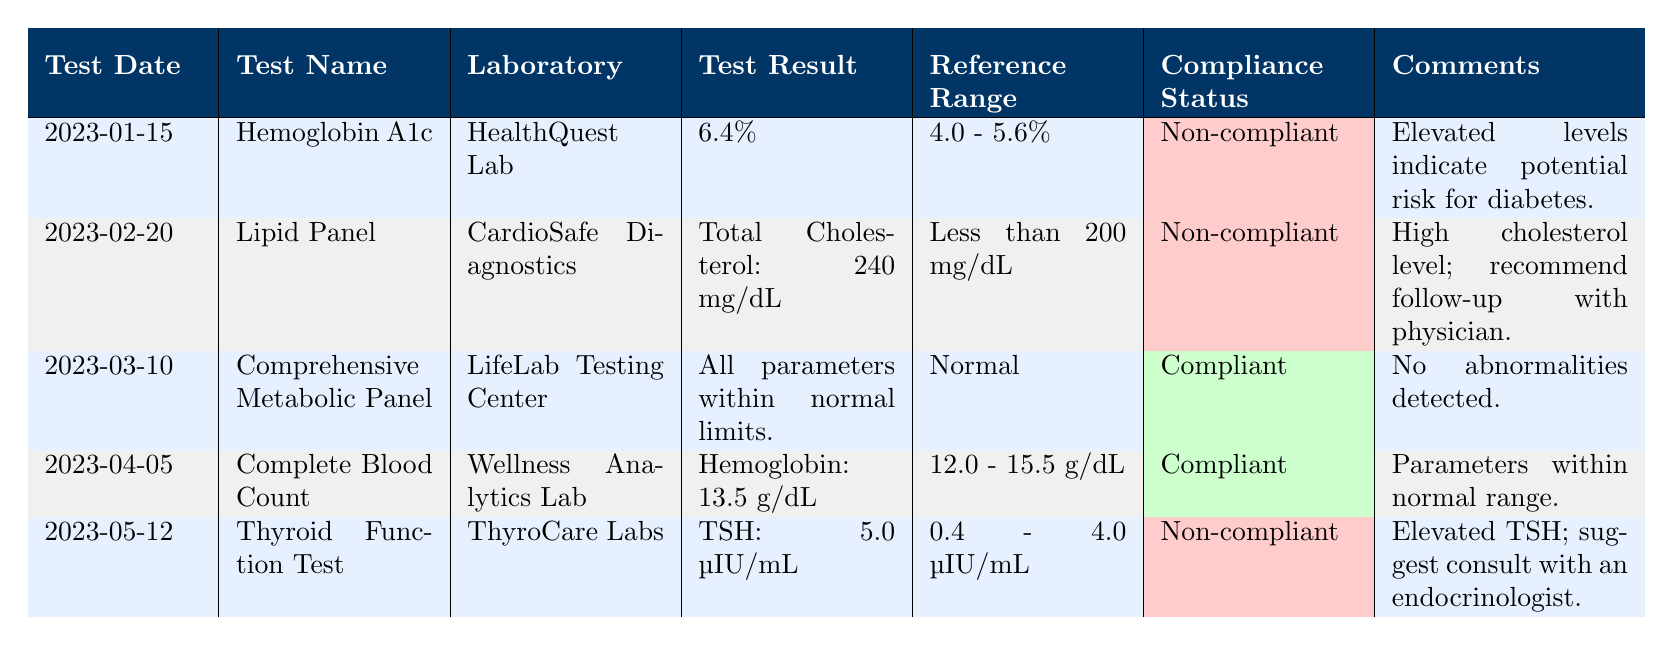What is the compliance status of the Hemoglobin A1c test? The table shows that the compliance status for the Hemoglobin A1c test conducted on January 15, 2023, is "Non-compliant."
Answer: Non-compliant How many tests are listed as compliant? By checking the compliance status of all tests in the table, we find that both the Comprehensive Metabolic Panel and the Complete Blood Count are listed as compliant, totaling 2 compliant tests.
Answer: 2 Which laboratory conducted the Lipid Panel test? According to the table, the Lipid Panel test was conducted by CardioSafe Diagnostics.
Answer: CardioSafe Diagnostics Is the TSH result from the Thyroid Function Test within the reference range? The TSH result of 5.0 µIU/mL exceeds the reference range of 0.4 - 4.0 µIU/mL, indicating that it is not within the reference range.
Answer: No What is the average value of the Hemoglobin in the tests listed? There is only one relevant measurement for Hemoglobin, which is 13.5 g/dL from the Complete Blood Count on April 5, 2023. Since it's the only value, the average is also 13.5 g/dL.
Answer: 13.5 g/dL What recommendation was provided for the Lipid Panel test? The comments section for the Lipid Panel test specifically states, "High cholesterol level; recommend follow-up with physician," which describes the recommendation based on the result.
Answer: Follow-up with physician What percentage of the tests are non-compliant based on the table? There are 5 tests in total, and 3 of them are non-compliant (the Hemoglobin A1c, Lipid Panel, and Thyroid Function Test). To find the percentage of non-compliant tests, we calculate (3/5) * 100% = 60%.
Answer: 60% Which test has the most recent date and what is its compliance status? The most recent test date is May 12, 2023, for the Thyroid Function Test. The compliance status for this test is "Non-compliant."
Answer: Non-compliant What is the range of reference values for the Hemoglobin A1c test? In the table, the reference range for the Hemoglobin A1c test is specified as 4.0 - 5.6%.
Answer: 4.0 - 5.6% 